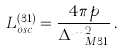<formula> <loc_0><loc_0><loc_500><loc_500>L _ { o s c } ^ { ( 3 1 ) } = \frac { 4 \pi p } { \Delta { m } ^ { 2 } _ { M 3 1 } } \, .</formula> 